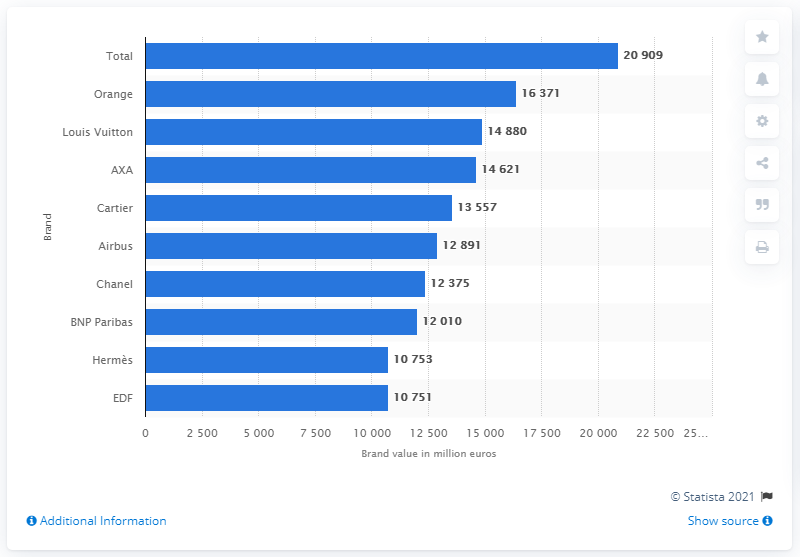Draw attention to some important aspects in this diagram. In 2020, the value of Orange was approximately 16,371. 